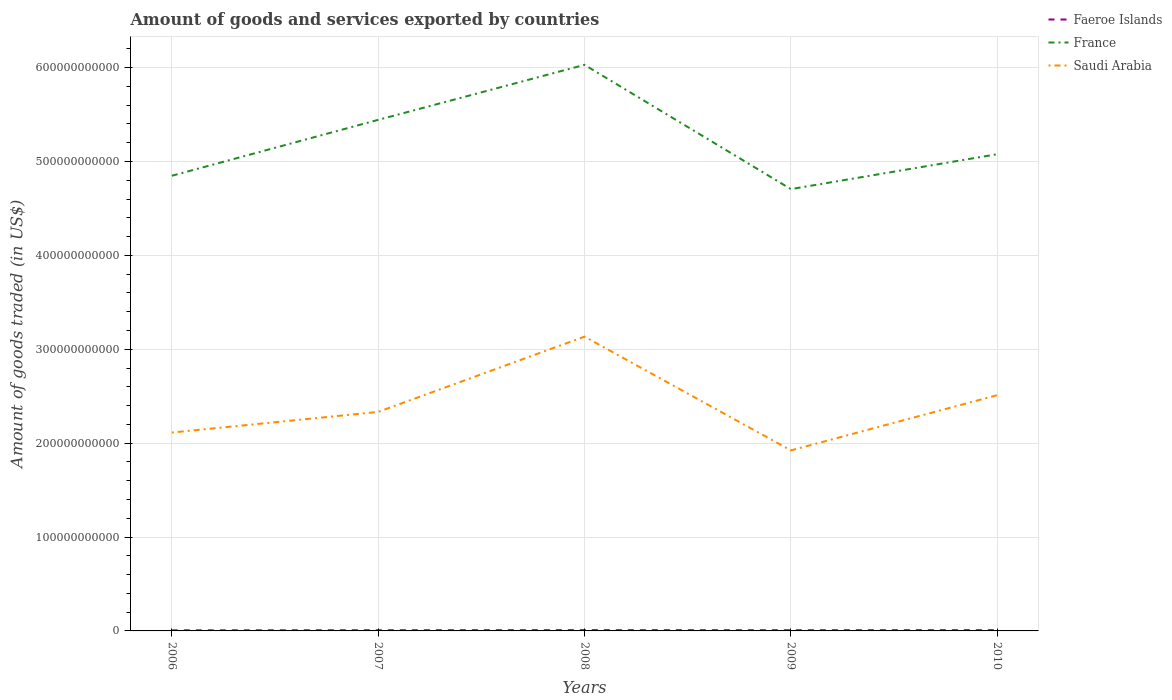How many different coloured lines are there?
Provide a succinct answer. 3. Does the line corresponding to Faeroe Islands intersect with the line corresponding to France?
Make the answer very short. No. Across all years, what is the maximum total amount of goods and services exported in Faeroe Islands?
Your answer should be very brief. 6.51e+08. In which year was the total amount of goods and services exported in France maximum?
Ensure brevity in your answer.  2009. What is the total total amount of goods and services exported in France in the graph?
Ensure brevity in your answer.  1.32e+11. What is the difference between the highest and the second highest total amount of goods and services exported in France?
Your answer should be compact. 1.32e+11. What is the difference between the highest and the lowest total amount of goods and services exported in Saudi Arabia?
Keep it short and to the point. 2. How many years are there in the graph?
Offer a very short reply. 5. What is the difference between two consecutive major ticks on the Y-axis?
Give a very brief answer. 1.00e+11. Are the values on the major ticks of Y-axis written in scientific E-notation?
Provide a short and direct response. No. Does the graph contain any zero values?
Provide a short and direct response. No. Does the graph contain grids?
Give a very brief answer. Yes. Where does the legend appear in the graph?
Your answer should be compact. Top right. How many legend labels are there?
Provide a short and direct response. 3. What is the title of the graph?
Provide a short and direct response. Amount of goods and services exported by countries. Does "Guam" appear as one of the legend labels in the graph?
Make the answer very short. No. What is the label or title of the Y-axis?
Ensure brevity in your answer.  Amount of goods traded (in US$). What is the Amount of goods traded (in US$) of Faeroe Islands in 2006?
Your response must be concise. 6.51e+08. What is the Amount of goods traded (in US$) in France in 2006?
Offer a terse response. 4.85e+11. What is the Amount of goods traded (in US$) in Saudi Arabia in 2006?
Your response must be concise. 2.11e+11. What is the Amount of goods traded (in US$) of Faeroe Islands in 2007?
Ensure brevity in your answer.  7.45e+08. What is the Amount of goods traded (in US$) in France in 2007?
Your answer should be very brief. 5.44e+11. What is the Amount of goods traded (in US$) of Saudi Arabia in 2007?
Your answer should be compact. 2.33e+11. What is the Amount of goods traded (in US$) of Faeroe Islands in 2008?
Make the answer very short. 8.52e+08. What is the Amount of goods traded (in US$) of France in 2008?
Ensure brevity in your answer.  6.03e+11. What is the Amount of goods traded (in US$) in Saudi Arabia in 2008?
Ensure brevity in your answer.  3.13e+11. What is the Amount of goods traded (in US$) of Faeroe Islands in 2009?
Your answer should be compact. 7.66e+08. What is the Amount of goods traded (in US$) of France in 2009?
Offer a very short reply. 4.71e+11. What is the Amount of goods traded (in US$) in Saudi Arabia in 2009?
Your response must be concise. 1.92e+11. What is the Amount of goods traded (in US$) of Faeroe Islands in 2010?
Offer a terse response. 8.35e+08. What is the Amount of goods traded (in US$) of France in 2010?
Make the answer very short. 5.08e+11. What is the Amount of goods traded (in US$) of Saudi Arabia in 2010?
Offer a terse response. 2.51e+11. Across all years, what is the maximum Amount of goods traded (in US$) of Faeroe Islands?
Your answer should be compact. 8.52e+08. Across all years, what is the maximum Amount of goods traded (in US$) in France?
Your answer should be very brief. 6.03e+11. Across all years, what is the maximum Amount of goods traded (in US$) in Saudi Arabia?
Your response must be concise. 3.13e+11. Across all years, what is the minimum Amount of goods traded (in US$) of Faeroe Islands?
Offer a very short reply. 6.51e+08. Across all years, what is the minimum Amount of goods traded (in US$) of France?
Your answer should be very brief. 4.71e+11. Across all years, what is the minimum Amount of goods traded (in US$) of Saudi Arabia?
Give a very brief answer. 1.92e+11. What is the total Amount of goods traded (in US$) in Faeroe Islands in the graph?
Keep it short and to the point. 3.85e+09. What is the total Amount of goods traded (in US$) in France in the graph?
Offer a very short reply. 2.61e+12. What is the total Amount of goods traded (in US$) in Saudi Arabia in the graph?
Your response must be concise. 1.20e+12. What is the difference between the Amount of goods traded (in US$) of Faeroe Islands in 2006 and that in 2007?
Your response must be concise. -9.46e+07. What is the difference between the Amount of goods traded (in US$) in France in 2006 and that in 2007?
Your response must be concise. -5.96e+1. What is the difference between the Amount of goods traded (in US$) of Saudi Arabia in 2006 and that in 2007?
Give a very brief answer. -2.20e+1. What is the difference between the Amount of goods traded (in US$) of Faeroe Islands in 2006 and that in 2008?
Give a very brief answer. -2.02e+08. What is the difference between the Amount of goods traded (in US$) in France in 2006 and that in 2008?
Offer a very short reply. -1.18e+11. What is the difference between the Amount of goods traded (in US$) in Saudi Arabia in 2006 and that in 2008?
Offer a terse response. -1.02e+11. What is the difference between the Amount of goods traded (in US$) in Faeroe Islands in 2006 and that in 2009?
Provide a short and direct response. -1.15e+08. What is the difference between the Amount of goods traded (in US$) in France in 2006 and that in 2009?
Your answer should be compact. 1.42e+1. What is the difference between the Amount of goods traded (in US$) in Saudi Arabia in 2006 and that in 2009?
Offer a very short reply. 1.90e+1. What is the difference between the Amount of goods traded (in US$) of Faeroe Islands in 2006 and that in 2010?
Keep it short and to the point. -1.85e+08. What is the difference between the Amount of goods traded (in US$) of France in 2006 and that in 2010?
Offer a terse response. -2.30e+1. What is the difference between the Amount of goods traded (in US$) in Saudi Arabia in 2006 and that in 2010?
Your answer should be very brief. -3.98e+1. What is the difference between the Amount of goods traded (in US$) in Faeroe Islands in 2007 and that in 2008?
Offer a terse response. -1.07e+08. What is the difference between the Amount of goods traded (in US$) in France in 2007 and that in 2008?
Offer a terse response. -5.86e+1. What is the difference between the Amount of goods traded (in US$) in Saudi Arabia in 2007 and that in 2008?
Give a very brief answer. -8.02e+1. What is the difference between the Amount of goods traded (in US$) of Faeroe Islands in 2007 and that in 2009?
Offer a very short reply. -2.05e+07. What is the difference between the Amount of goods traded (in US$) in France in 2007 and that in 2009?
Give a very brief answer. 7.38e+1. What is the difference between the Amount of goods traded (in US$) of Saudi Arabia in 2007 and that in 2009?
Make the answer very short. 4.10e+1. What is the difference between the Amount of goods traded (in US$) in Faeroe Islands in 2007 and that in 2010?
Your response must be concise. -8.99e+07. What is the difference between the Amount of goods traded (in US$) of France in 2007 and that in 2010?
Offer a very short reply. 3.66e+1. What is the difference between the Amount of goods traded (in US$) of Saudi Arabia in 2007 and that in 2010?
Provide a short and direct response. -1.78e+1. What is the difference between the Amount of goods traded (in US$) in Faeroe Islands in 2008 and that in 2009?
Your response must be concise. 8.67e+07. What is the difference between the Amount of goods traded (in US$) in France in 2008 and that in 2009?
Ensure brevity in your answer.  1.32e+11. What is the difference between the Amount of goods traded (in US$) of Saudi Arabia in 2008 and that in 2009?
Ensure brevity in your answer.  1.21e+11. What is the difference between the Amount of goods traded (in US$) in Faeroe Islands in 2008 and that in 2010?
Make the answer very short. 1.73e+07. What is the difference between the Amount of goods traded (in US$) in France in 2008 and that in 2010?
Keep it short and to the point. 9.52e+1. What is the difference between the Amount of goods traded (in US$) in Saudi Arabia in 2008 and that in 2010?
Provide a short and direct response. 6.23e+1. What is the difference between the Amount of goods traded (in US$) in Faeroe Islands in 2009 and that in 2010?
Give a very brief answer. -6.94e+07. What is the difference between the Amount of goods traded (in US$) in France in 2009 and that in 2010?
Your response must be concise. -3.72e+1. What is the difference between the Amount of goods traded (in US$) in Saudi Arabia in 2009 and that in 2010?
Your answer should be very brief. -5.88e+1. What is the difference between the Amount of goods traded (in US$) of Faeroe Islands in 2006 and the Amount of goods traded (in US$) of France in 2007?
Provide a short and direct response. -5.44e+11. What is the difference between the Amount of goods traded (in US$) in Faeroe Islands in 2006 and the Amount of goods traded (in US$) in Saudi Arabia in 2007?
Your answer should be compact. -2.33e+11. What is the difference between the Amount of goods traded (in US$) of France in 2006 and the Amount of goods traded (in US$) of Saudi Arabia in 2007?
Your answer should be compact. 2.52e+11. What is the difference between the Amount of goods traded (in US$) of Faeroe Islands in 2006 and the Amount of goods traded (in US$) of France in 2008?
Make the answer very short. -6.02e+11. What is the difference between the Amount of goods traded (in US$) of Faeroe Islands in 2006 and the Amount of goods traded (in US$) of Saudi Arabia in 2008?
Your response must be concise. -3.13e+11. What is the difference between the Amount of goods traded (in US$) of France in 2006 and the Amount of goods traded (in US$) of Saudi Arabia in 2008?
Your answer should be very brief. 1.71e+11. What is the difference between the Amount of goods traded (in US$) in Faeroe Islands in 2006 and the Amount of goods traded (in US$) in France in 2009?
Give a very brief answer. -4.70e+11. What is the difference between the Amount of goods traded (in US$) in Faeroe Islands in 2006 and the Amount of goods traded (in US$) in Saudi Arabia in 2009?
Make the answer very short. -1.92e+11. What is the difference between the Amount of goods traded (in US$) in France in 2006 and the Amount of goods traded (in US$) in Saudi Arabia in 2009?
Provide a short and direct response. 2.93e+11. What is the difference between the Amount of goods traded (in US$) of Faeroe Islands in 2006 and the Amount of goods traded (in US$) of France in 2010?
Give a very brief answer. -5.07e+11. What is the difference between the Amount of goods traded (in US$) of Faeroe Islands in 2006 and the Amount of goods traded (in US$) of Saudi Arabia in 2010?
Provide a short and direct response. -2.50e+11. What is the difference between the Amount of goods traded (in US$) of France in 2006 and the Amount of goods traded (in US$) of Saudi Arabia in 2010?
Provide a succinct answer. 2.34e+11. What is the difference between the Amount of goods traded (in US$) of Faeroe Islands in 2007 and the Amount of goods traded (in US$) of France in 2008?
Keep it short and to the point. -6.02e+11. What is the difference between the Amount of goods traded (in US$) in Faeroe Islands in 2007 and the Amount of goods traded (in US$) in Saudi Arabia in 2008?
Your answer should be compact. -3.13e+11. What is the difference between the Amount of goods traded (in US$) of France in 2007 and the Amount of goods traded (in US$) of Saudi Arabia in 2008?
Provide a short and direct response. 2.31e+11. What is the difference between the Amount of goods traded (in US$) of Faeroe Islands in 2007 and the Amount of goods traded (in US$) of France in 2009?
Provide a short and direct response. -4.70e+11. What is the difference between the Amount of goods traded (in US$) of Faeroe Islands in 2007 and the Amount of goods traded (in US$) of Saudi Arabia in 2009?
Provide a succinct answer. -1.92e+11. What is the difference between the Amount of goods traded (in US$) of France in 2007 and the Amount of goods traded (in US$) of Saudi Arabia in 2009?
Give a very brief answer. 3.52e+11. What is the difference between the Amount of goods traded (in US$) of Faeroe Islands in 2007 and the Amount of goods traded (in US$) of France in 2010?
Provide a short and direct response. -5.07e+11. What is the difference between the Amount of goods traded (in US$) in Faeroe Islands in 2007 and the Amount of goods traded (in US$) in Saudi Arabia in 2010?
Offer a very short reply. -2.50e+11. What is the difference between the Amount of goods traded (in US$) of France in 2007 and the Amount of goods traded (in US$) of Saudi Arabia in 2010?
Provide a succinct answer. 2.93e+11. What is the difference between the Amount of goods traded (in US$) in Faeroe Islands in 2008 and the Amount of goods traded (in US$) in France in 2009?
Your answer should be very brief. -4.70e+11. What is the difference between the Amount of goods traded (in US$) in Faeroe Islands in 2008 and the Amount of goods traded (in US$) in Saudi Arabia in 2009?
Your answer should be very brief. -1.91e+11. What is the difference between the Amount of goods traded (in US$) of France in 2008 and the Amount of goods traded (in US$) of Saudi Arabia in 2009?
Keep it short and to the point. 4.11e+11. What is the difference between the Amount of goods traded (in US$) of Faeroe Islands in 2008 and the Amount of goods traded (in US$) of France in 2010?
Offer a terse response. -5.07e+11. What is the difference between the Amount of goods traded (in US$) in Faeroe Islands in 2008 and the Amount of goods traded (in US$) in Saudi Arabia in 2010?
Your answer should be compact. -2.50e+11. What is the difference between the Amount of goods traded (in US$) in France in 2008 and the Amount of goods traded (in US$) in Saudi Arabia in 2010?
Offer a very short reply. 3.52e+11. What is the difference between the Amount of goods traded (in US$) in Faeroe Islands in 2009 and the Amount of goods traded (in US$) in France in 2010?
Give a very brief answer. -5.07e+11. What is the difference between the Amount of goods traded (in US$) of Faeroe Islands in 2009 and the Amount of goods traded (in US$) of Saudi Arabia in 2010?
Offer a very short reply. -2.50e+11. What is the difference between the Amount of goods traded (in US$) in France in 2009 and the Amount of goods traded (in US$) in Saudi Arabia in 2010?
Your response must be concise. 2.19e+11. What is the average Amount of goods traded (in US$) in Faeroe Islands per year?
Provide a succinct answer. 7.70e+08. What is the average Amount of goods traded (in US$) in France per year?
Keep it short and to the point. 5.22e+11. What is the average Amount of goods traded (in US$) of Saudi Arabia per year?
Ensure brevity in your answer.  2.40e+11. In the year 2006, what is the difference between the Amount of goods traded (in US$) in Faeroe Islands and Amount of goods traded (in US$) in France?
Provide a succinct answer. -4.84e+11. In the year 2006, what is the difference between the Amount of goods traded (in US$) in Faeroe Islands and Amount of goods traded (in US$) in Saudi Arabia?
Provide a succinct answer. -2.11e+11. In the year 2006, what is the difference between the Amount of goods traded (in US$) of France and Amount of goods traded (in US$) of Saudi Arabia?
Give a very brief answer. 2.74e+11. In the year 2007, what is the difference between the Amount of goods traded (in US$) in Faeroe Islands and Amount of goods traded (in US$) in France?
Your answer should be very brief. -5.44e+11. In the year 2007, what is the difference between the Amount of goods traded (in US$) of Faeroe Islands and Amount of goods traded (in US$) of Saudi Arabia?
Your answer should be very brief. -2.33e+11. In the year 2007, what is the difference between the Amount of goods traded (in US$) in France and Amount of goods traded (in US$) in Saudi Arabia?
Keep it short and to the point. 3.11e+11. In the year 2008, what is the difference between the Amount of goods traded (in US$) in Faeroe Islands and Amount of goods traded (in US$) in France?
Keep it short and to the point. -6.02e+11. In the year 2008, what is the difference between the Amount of goods traded (in US$) of Faeroe Islands and Amount of goods traded (in US$) of Saudi Arabia?
Keep it short and to the point. -3.13e+11. In the year 2008, what is the difference between the Amount of goods traded (in US$) of France and Amount of goods traded (in US$) of Saudi Arabia?
Keep it short and to the point. 2.90e+11. In the year 2009, what is the difference between the Amount of goods traded (in US$) in Faeroe Islands and Amount of goods traded (in US$) in France?
Your answer should be very brief. -4.70e+11. In the year 2009, what is the difference between the Amount of goods traded (in US$) of Faeroe Islands and Amount of goods traded (in US$) of Saudi Arabia?
Provide a short and direct response. -1.92e+11. In the year 2009, what is the difference between the Amount of goods traded (in US$) of France and Amount of goods traded (in US$) of Saudi Arabia?
Your response must be concise. 2.78e+11. In the year 2010, what is the difference between the Amount of goods traded (in US$) in Faeroe Islands and Amount of goods traded (in US$) in France?
Provide a succinct answer. -5.07e+11. In the year 2010, what is the difference between the Amount of goods traded (in US$) of Faeroe Islands and Amount of goods traded (in US$) of Saudi Arabia?
Your response must be concise. -2.50e+11. In the year 2010, what is the difference between the Amount of goods traded (in US$) of France and Amount of goods traded (in US$) of Saudi Arabia?
Offer a terse response. 2.57e+11. What is the ratio of the Amount of goods traded (in US$) in Faeroe Islands in 2006 to that in 2007?
Your answer should be very brief. 0.87. What is the ratio of the Amount of goods traded (in US$) of France in 2006 to that in 2007?
Offer a terse response. 0.89. What is the ratio of the Amount of goods traded (in US$) of Saudi Arabia in 2006 to that in 2007?
Offer a very short reply. 0.91. What is the ratio of the Amount of goods traded (in US$) in Faeroe Islands in 2006 to that in 2008?
Your response must be concise. 0.76. What is the ratio of the Amount of goods traded (in US$) of France in 2006 to that in 2008?
Offer a terse response. 0.8. What is the ratio of the Amount of goods traded (in US$) of Saudi Arabia in 2006 to that in 2008?
Your answer should be very brief. 0.67. What is the ratio of the Amount of goods traded (in US$) of Faeroe Islands in 2006 to that in 2009?
Offer a terse response. 0.85. What is the ratio of the Amount of goods traded (in US$) in France in 2006 to that in 2009?
Offer a terse response. 1.03. What is the ratio of the Amount of goods traded (in US$) of Saudi Arabia in 2006 to that in 2009?
Ensure brevity in your answer.  1.1. What is the ratio of the Amount of goods traded (in US$) in Faeroe Islands in 2006 to that in 2010?
Offer a terse response. 0.78. What is the ratio of the Amount of goods traded (in US$) in France in 2006 to that in 2010?
Your answer should be compact. 0.95. What is the ratio of the Amount of goods traded (in US$) in Saudi Arabia in 2006 to that in 2010?
Offer a very short reply. 0.84. What is the ratio of the Amount of goods traded (in US$) of Faeroe Islands in 2007 to that in 2008?
Provide a short and direct response. 0.87. What is the ratio of the Amount of goods traded (in US$) in France in 2007 to that in 2008?
Offer a very short reply. 0.9. What is the ratio of the Amount of goods traded (in US$) of Saudi Arabia in 2007 to that in 2008?
Ensure brevity in your answer.  0.74. What is the ratio of the Amount of goods traded (in US$) in Faeroe Islands in 2007 to that in 2009?
Keep it short and to the point. 0.97. What is the ratio of the Amount of goods traded (in US$) of France in 2007 to that in 2009?
Make the answer very short. 1.16. What is the ratio of the Amount of goods traded (in US$) of Saudi Arabia in 2007 to that in 2009?
Your response must be concise. 1.21. What is the ratio of the Amount of goods traded (in US$) in Faeroe Islands in 2007 to that in 2010?
Provide a succinct answer. 0.89. What is the ratio of the Amount of goods traded (in US$) in France in 2007 to that in 2010?
Your response must be concise. 1.07. What is the ratio of the Amount of goods traded (in US$) in Saudi Arabia in 2007 to that in 2010?
Make the answer very short. 0.93. What is the ratio of the Amount of goods traded (in US$) in Faeroe Islands in 2008 to that in 2009?
Your answer should be very brief. 1.11. What is the ratio of the Amount of goods traded (in US$) in France in 2008 to that in 2009?
Your answer should be very brief. 1.28. What is the ratio of the Amount of goods traded (in US$) in Saudi Arabia in 2008 to that in 2009?
Your response must be concise. 1.63. What is the ratio of the Amount of goods traded (in US$) in Faeroe Islands in 2008 to that in 2010?
Provide a succinct answer. 1.02. What is the ratio of the Amount of goods traded (in US$) in France in 2008 to that in 2010?
Give a very brief answer. 1.19. What is the ratio of the Amount of goods traded (in US$) of Saudi Arabia in 2008 to that in 2010?
Your answer should be very brief. 1.25. What is the ratio of the Amount of goods traded (in US$) in Faeroe Islands in 2009 to that in 2010?
Offer a very short reply. 0.92. What is the ratio of the Amount of goods traded (in US$) of France in 2009 to that in 2010?
Offer a very short reply. 0.93. What is the ratio of the Amount of goods traded (in US$) of Saudi Arabia in 2009 to that in 2010?
Provide a succinct answer. 0.77. What is the difference between the highest and the second highest Amount of goods traded (in US$) in Faeroe Islands?
Provide a succinct answer. 1.73e+07. What is the difference between the highest and the second highest Amount of goods traded (in US$) in France?
Ensure brevity in your answer.  5.86e+1. What is the difference between the highest and the second highest Amount of goods traded (in US$) of Saudi Arabia?
Your answer should be compact. 6.23e+1. What is the difference between the highest and the lowest Amount of goods traded (in US$) in Faeroe Islands?
Give a very brief answer. 2.02e+08. What is the difference between the highest and the lowest Amount of goods traded (in US$) of France?
Your response must be concise. 1.32e+11. What is the difference between the highest and the lowest Amount of goods traded (in US$) in Saudi Arabia?
Ensure brevity in your answer.  1.21e+11. 